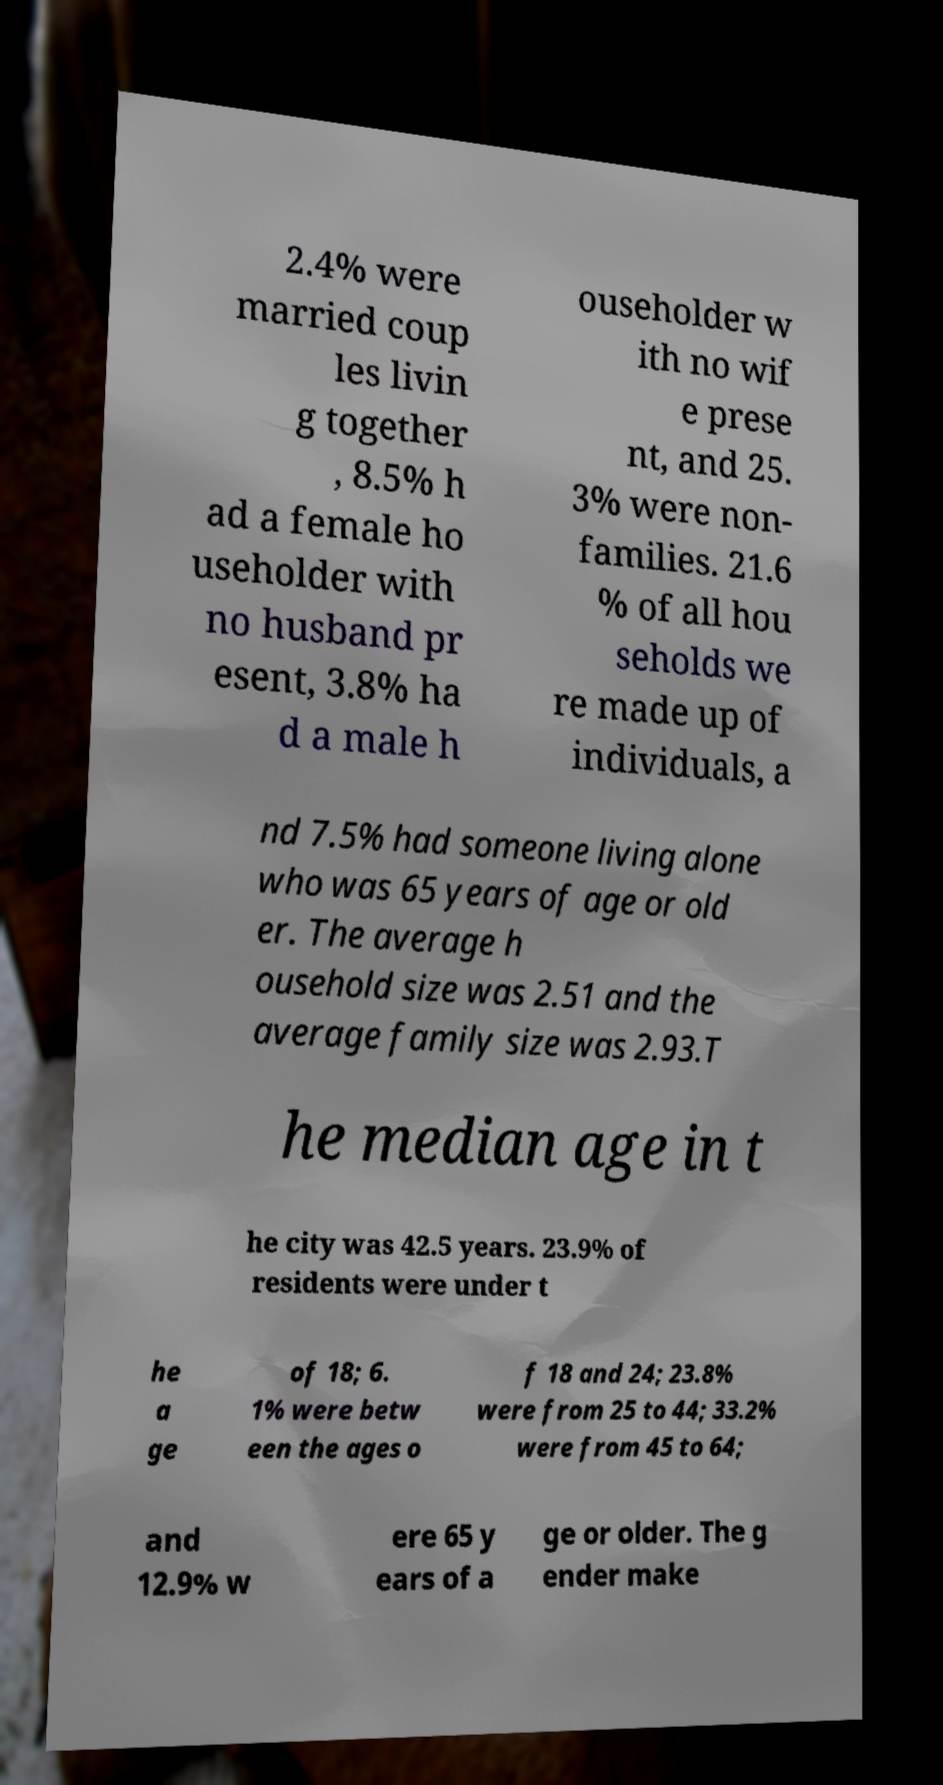Could you assist in decoding the text presented in this image and type it out clearly? 2.4% were married coup les livin g together , 8.5% h ad a female ho useholder with no husband pr esent, 3.8% ha d a male h ouseholder w ith no wif e prese nt, and 25. 3% were non- families. 21.6 % of all hou seholds we re made up of individuals, a nd 7.5% had someone living alone who was 65 years of age or old er. The average h ousehold size was 2.51 and the average family size was 2.93.T he median age in t he city was 42.5 years. 23.9% of residents were under t he a ge of 18; 6. 1% were betw een the ages o f 18 and 24; 23.8% were from 25 to 44; 33.2% were from 45 to 64; and 12.9% w ere 65 y ears of a ge or older. The g ender make 